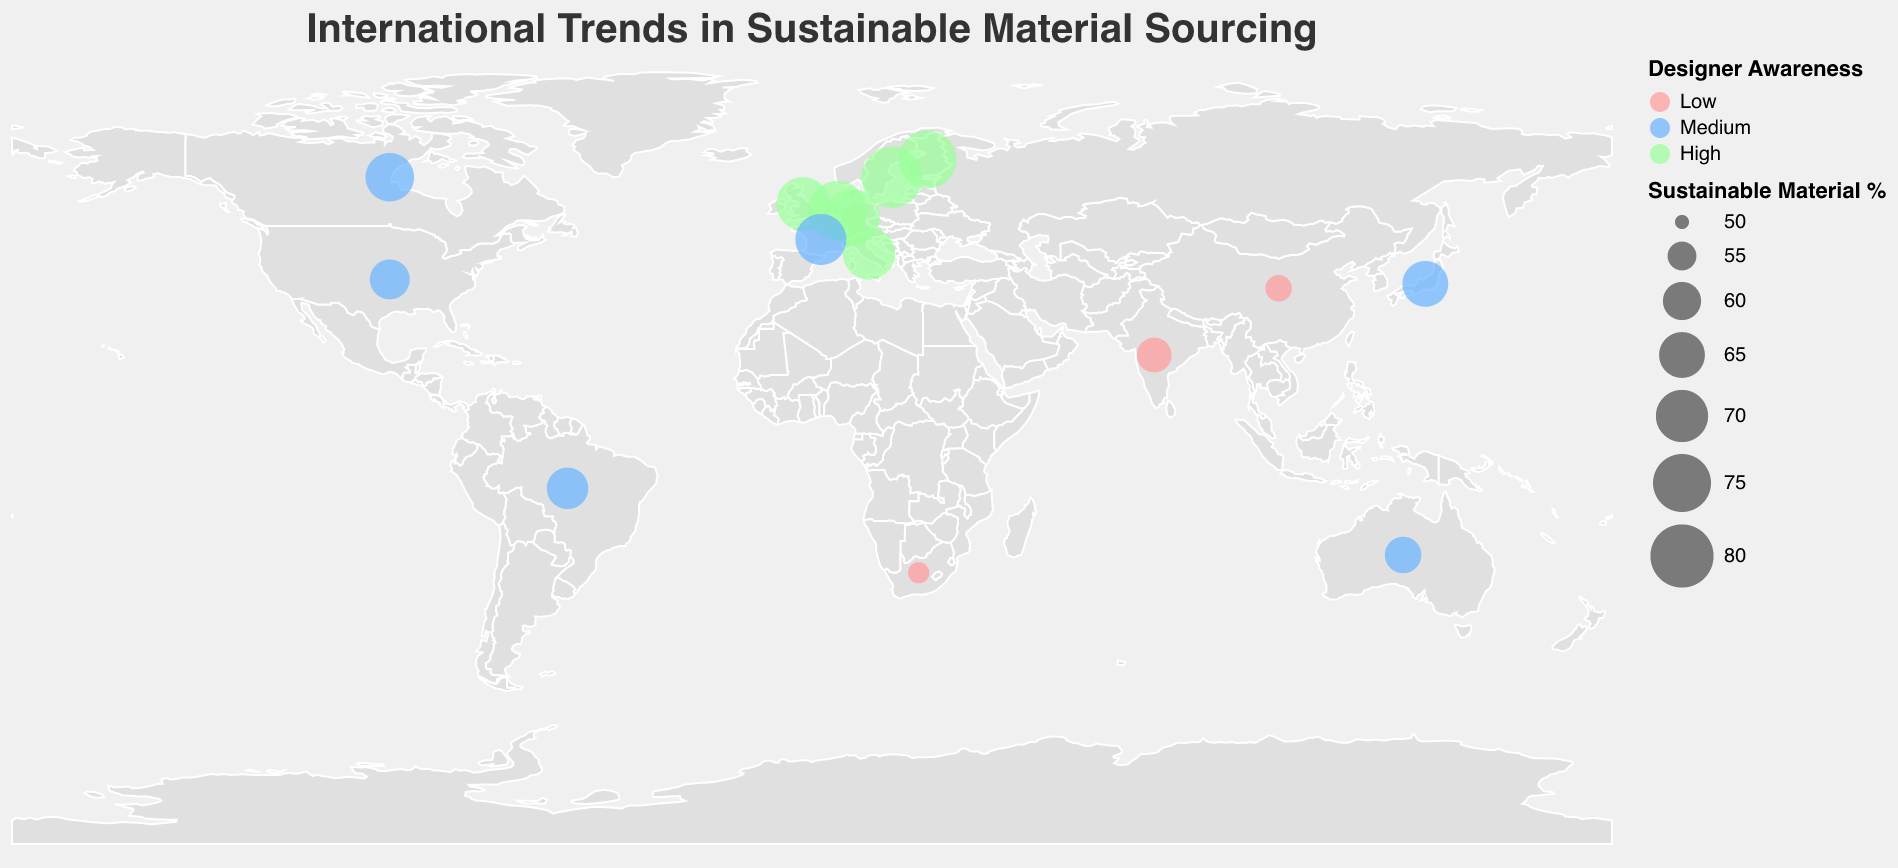What is the title of the plot? The title is located at the top center of the plot and provides a brief overview of what the plot represents.
Answer: International Trends in Sustainable Material Sourcing How many countries are included in the plot? Each country is represented by a circle on the plot. By counting the number of circles, we can determine the number of countries.
Answer: 15 Which country has the highest percentage of sustainable material sourcing? The percentage of sustainable material sourcing is indicated by the size of the circle. The largest circle corresponds to the highest percentage.
Answer: Sweden What is the top sustainable material in the United Kingdom? By referring to the tooltip information or identifying the specific circle for the United Kingdom, we can see the top sustainable material.
Answer: Organic Wool Which countries have high designer awareness? The designer awareness levels are represented by color. The countries with green circles have high designer awareness.
Answer: Sweden, Germany, Netherlands, Italy, United Kingdom, Finland What is the average percentage of sustainable material sourcing for countries with medium designer awareness? Identify the countries with blue circles (medium designer awareness), sum their sustainable material percentages, and divide by the number of these countries. The countries are Japan (65), Brazil (62), United States (61), Australia (59), Canada (67), and France (69). The sum is 65 + 62 + 61 + 59 + 67 + 69 = 383. There are 6 countries, so 383/6 = 63.83.
Answer: 63.83 Which country uses Bamboo Fiber as the top sustainable material? By examining the tooltip information for each circle, identify the one that lists Bamboo Fiber.
Answer: Japan Is the use of Mycelium more prevalent in the Netherlands or any other country? Check the sustainable material percentage for the Netherlands and compare it with other countries that might use Mycelium. The Netherlands has 76%, and no other country listed uses Mycelium.
Answer: More prevalent in the Netherlands Which three countries have the lowest percentages of sustainable material sourcing, and what are their percentages? Sort the countries by their percentages in ascending order and select the first three. The countries and their percentages are South Africa (52%), China (54%), and India (58%).
Answer: South Africa (52%), China (54%), and India (58%) 